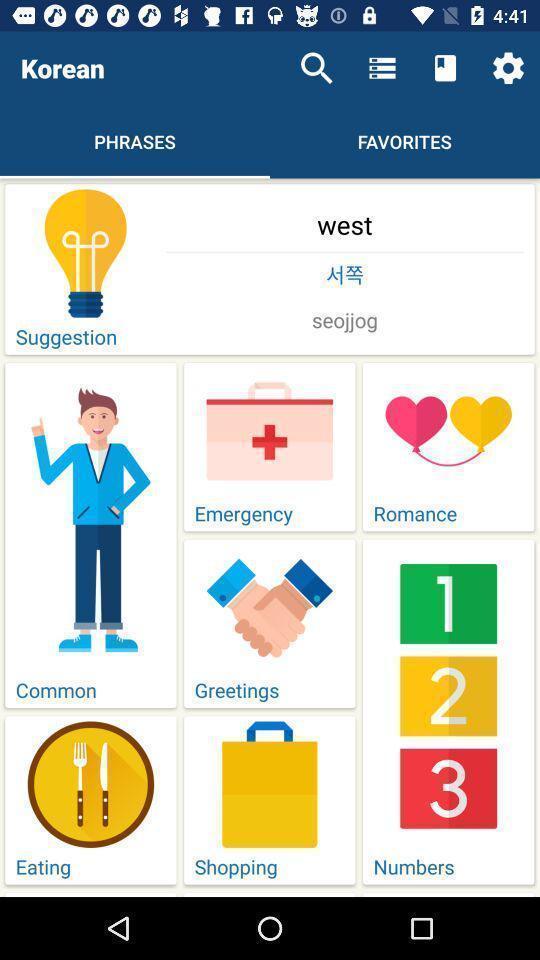Summarize the main components in this picture. Page showing various categories on app. 